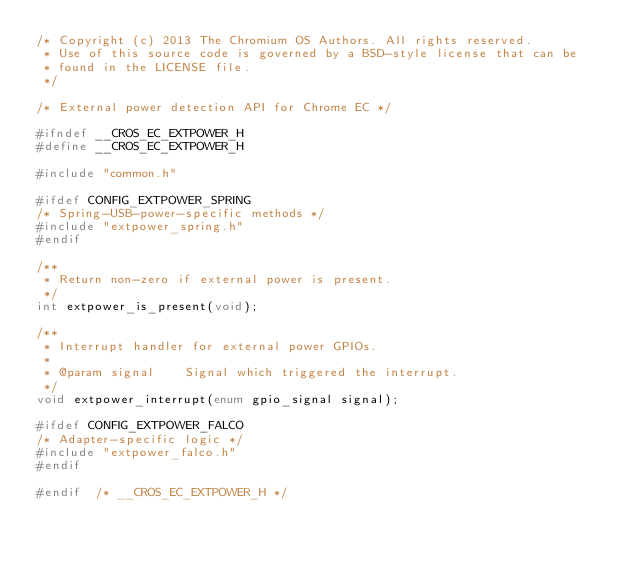Convert code to text. <code><loc_0><loc_0><loc_500><loc_500><_C_>/* Copyright (c) 2013 The Chromium OS Authors. All rights reserved.
 * Use of this source code is governed by a BSD-style license that can be
 * found in the LICENSE file.
 */

/* External power detection API for Chrome EC */

#ifndef __CROS_EC_EXTPOWER_H
#define __CROS_EC_EXTPOWER_H

#include "common.h"

#ifdef CONFIG_EXTPOWER_SPRING
/* Spring-USB-power-specific methods */
#include "extpower_spring.h"
#endif

/**
 * Return non-zero if external power is present.
 */
int extpower_is_present(void);

/**
 * Interrupt handler for external power GPIOs.
 *
 * @param signal	Signal which triggered the interrupt.
 */
void extpower_interrupt(enum gpio_signal signal);

#ifdef CONFIG_EXTPOWER_FALCO
/* Adapter-specific logic */
#include "extpower_falco.h"
#endif

#endif  /* __CROS_EC_EXTPOWER_H */
</code> 